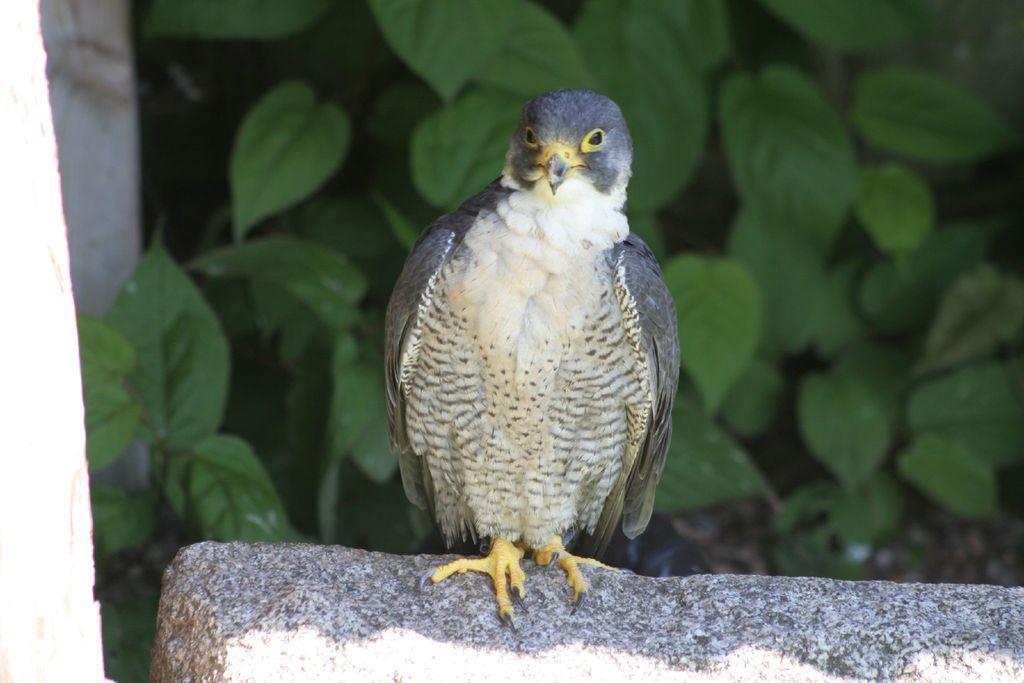Could you give a brief overview of what you see in this image? In front of the image there is a bird on the rock. Behind the rock there are plants. 